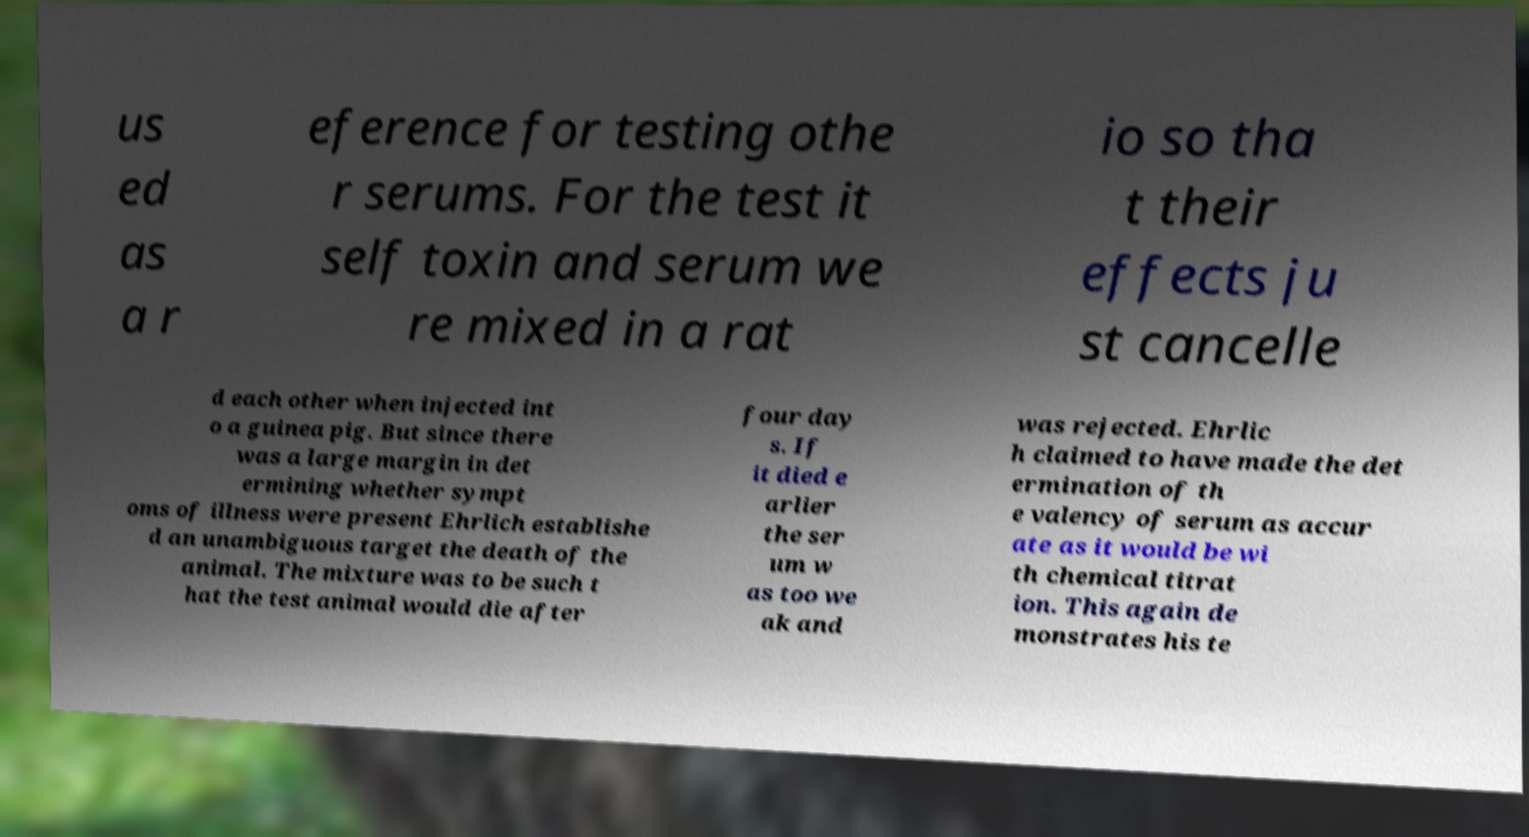Please read and relay the text visible in this image. What does it say? us ed as a r eference for testing othe r serums. For the test it self toxin and serum we re mixed in a rat io so tha t their effects ju st cancelle d each other when injected int o a guinea pig. But since there was a large margin in det ermining whether sympt oms of illness were present Ehrlich establishe d an unambiguous target the death of the animal. The mixture was to be such t hat the test animal would die after four day s. If it died e arlier the ser um w as too we ak and was rejected. Ehrlic h claimed to have made the det ermination of th e valency of serum as accur ate as it would be wi th chemical titrat ion. This again de monstrates his te 